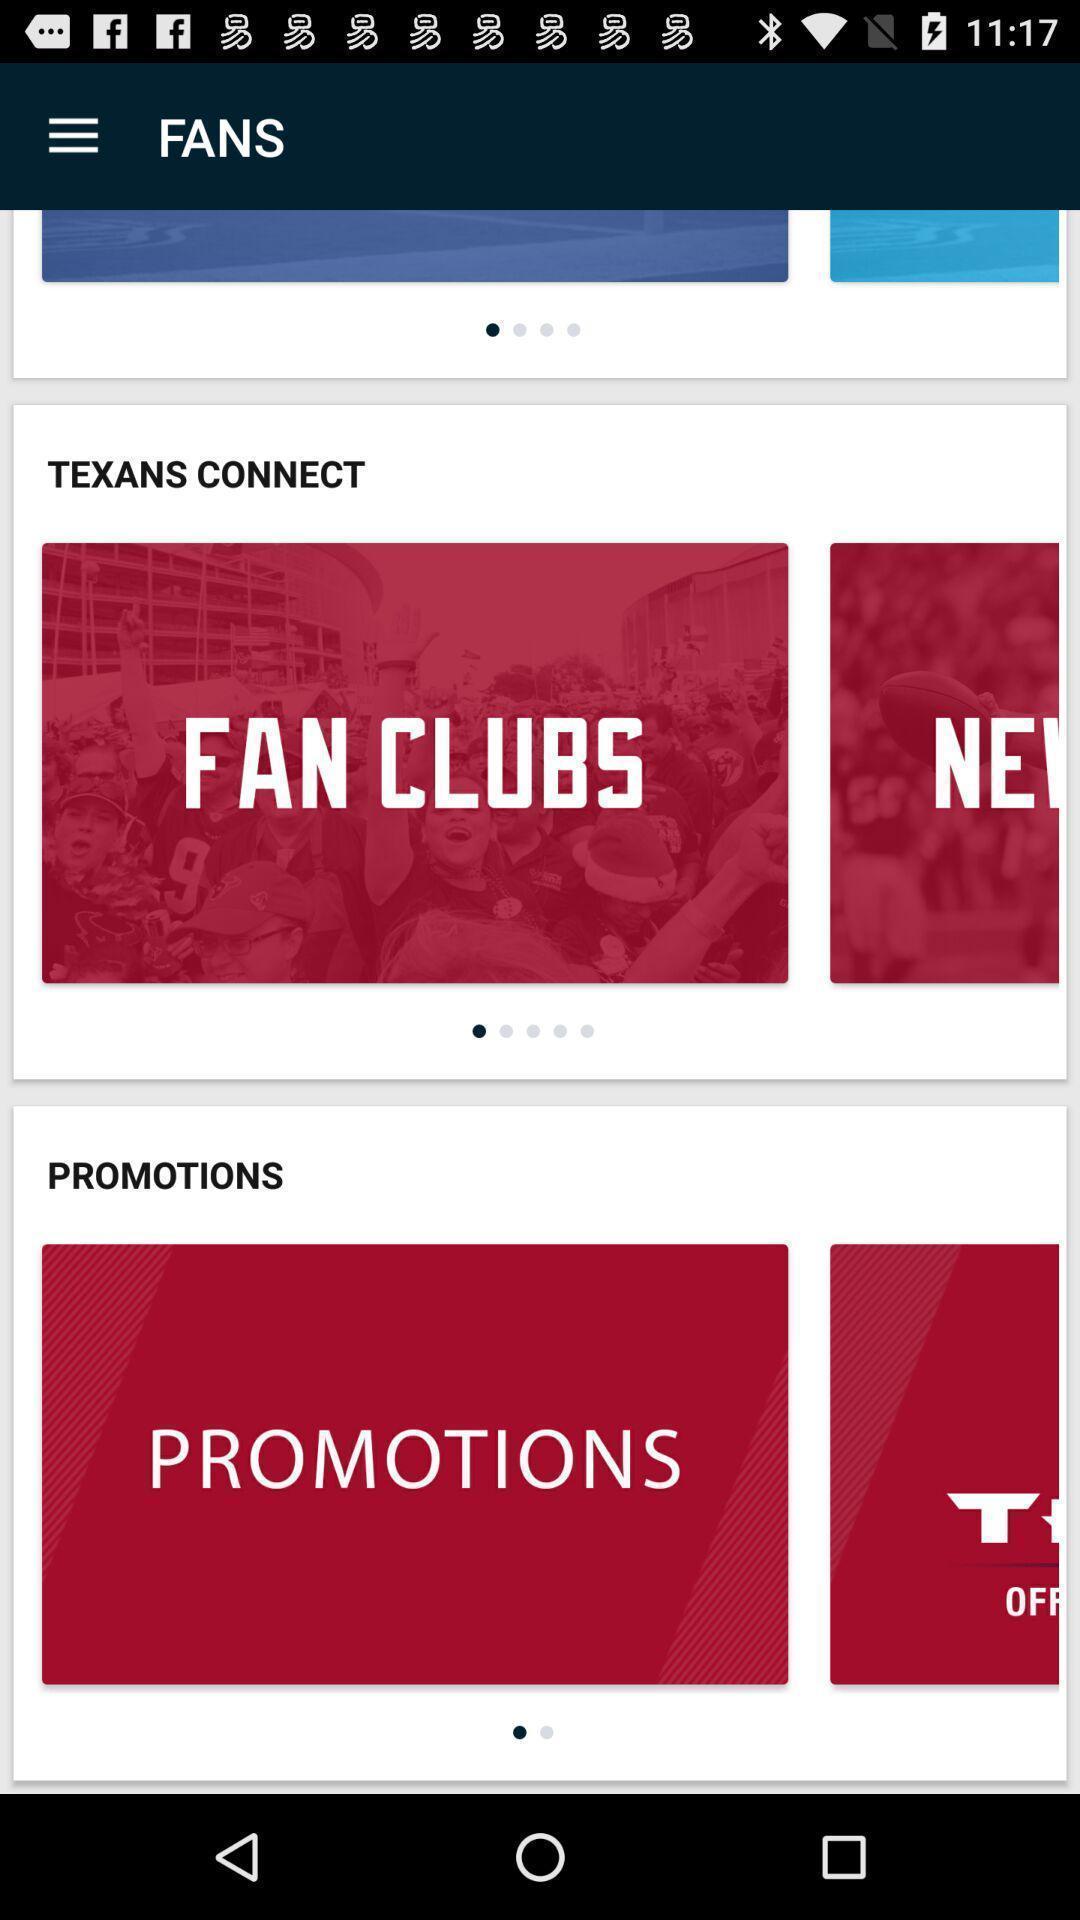Provide a detailed account of this screenshot. Screen shows fans page in sports application. 